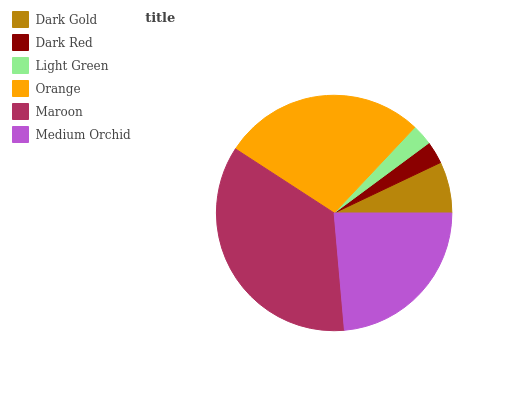Is Light Green the minimum?
Answer yes or no. Yes. Is Maroon the maximum?
Answer yes or no. Yes. Is Dark Red the minimum?
Answer yes or no. No. Is Dark Red the maximum?
Answer yes or no. No. Is Dark Gold greater than Dark Red?
Answer yes or no. Yes. Is Dark Red less than Dark Gold?
Answer yes or no. Yes. Is Dark Red greater than Dark Gold?
Answer yes or no. No. Is Dark Gold less than Dark Red?
Answer yes or no. No. Is Medium Orchid the high median?
Answer yes or no. Yes. Is Dark Gold the low median?
Answer yes or no. Yes. Is Light Green the high median?
Answer yes or no. No. Is Medium Orchid the low median?
Answer yes or no. No. 